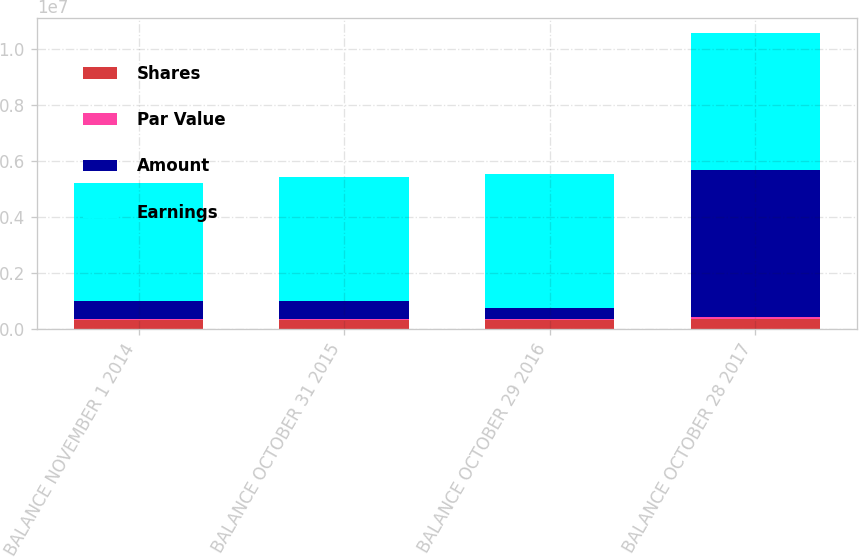Convert chart. <chart><loc_0><loc_0><loc_500><loc_500><stacked_bar_chart><ecel><fcel>BALANCE NOVEMBER 1 2014<fcel>BALANCE OCTOBER 31 2015<fcel>BALANCE OCTOBER 29 2016<fcel>BALANCE OCTOBER 28 2017<nl><fcel>Shares<fcel>311205<fcel>312061<fcel>308171<fcel>368636<nl><fcel>Par Value<fcel>51869<fcel>52011<fcel>51363<fcel>61441<nl><fcel>Amount<fcel>643058<fcel>634484<fcel>402270<fcel>5.25052e+06<nl><fcel>Earnings<fcel>4.2315e+06<fcel>4.43732e+06<fcel>4.7858e+06<fcel>4.91094e+06<nl></chart> 